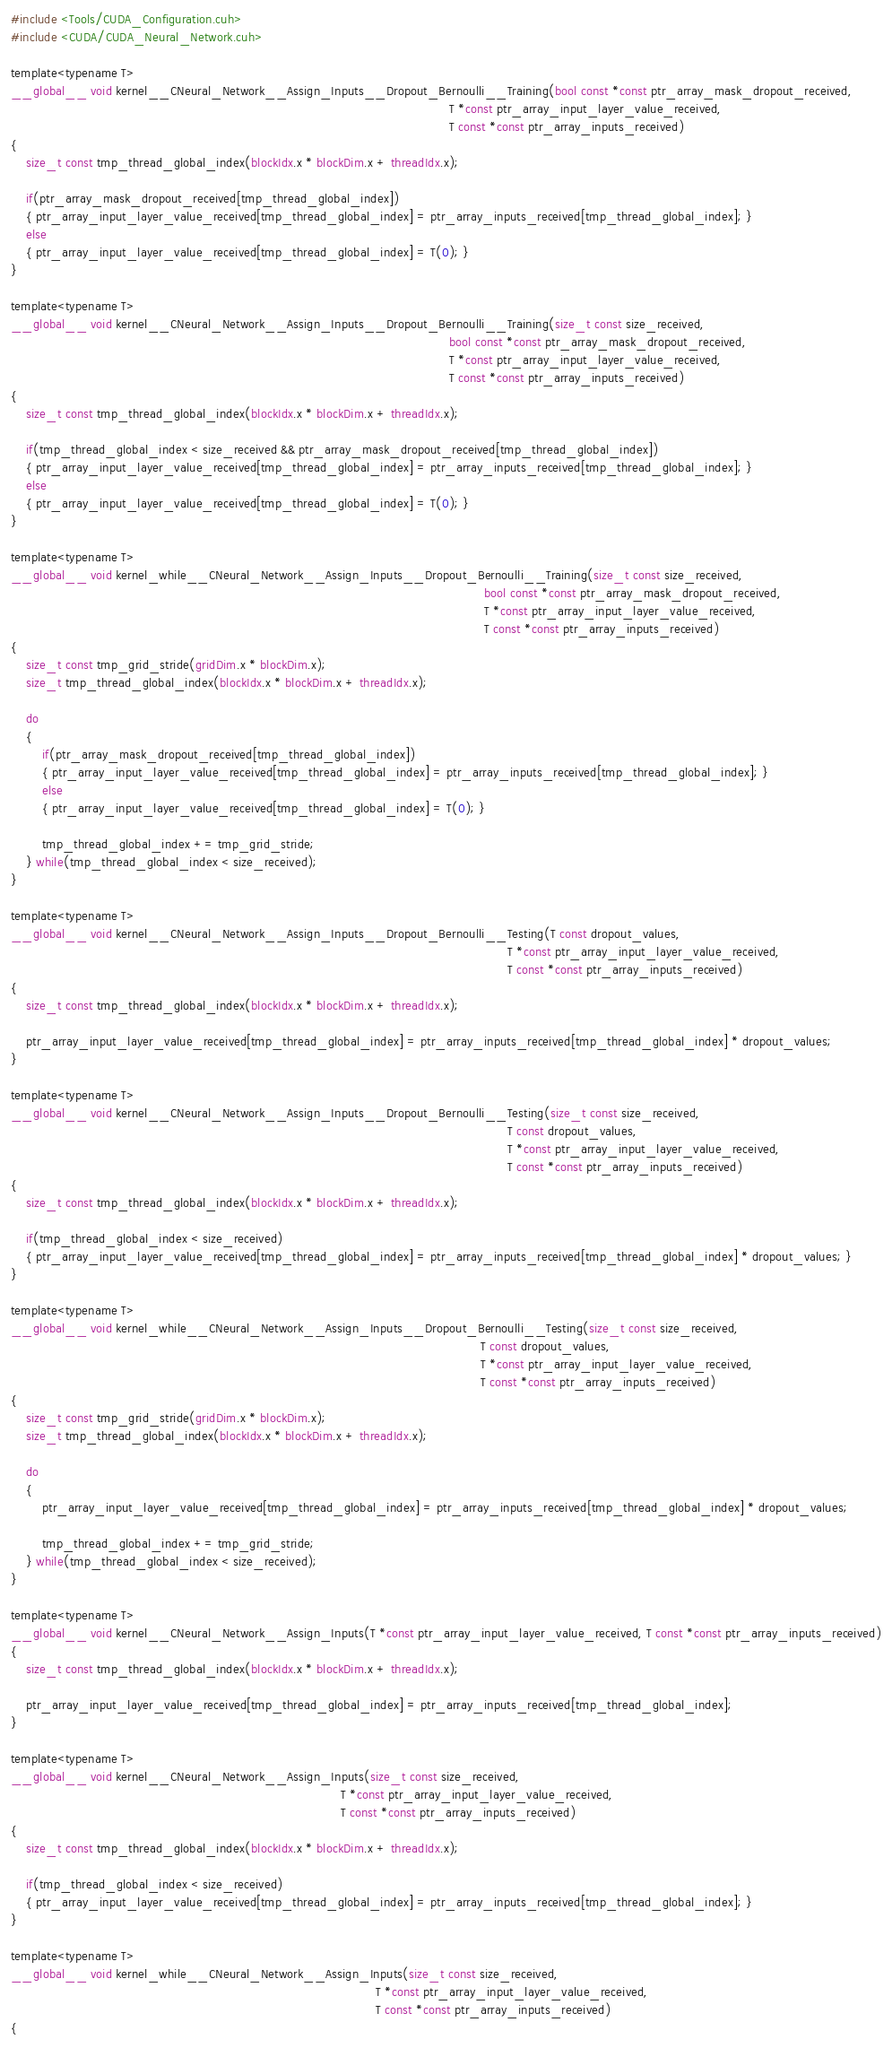<code> <loc_0><loc_0><loc_500><loc_500><_Cuda_>#include <Tools/CUDA_Configuration.cuh>
#include <CUDA/CUDA_Neural_Network.cuh>

template<typename T>
__global__ void kernel__CNeural_Network__Assign_Inputs__Dropout_Bernoulli__Training(bool const *const ptr_array_mask_dropout_received,
                                                                                                                 T *const ptr_array_input_layer_value_received,
                                                                                                                 T const *const ptr_array_inputs_received)
{
    size_t const tmp_thread_global_index(blockIdx.x * blockDim.x + threadIdx.x);
    
    if(ptr_array_mask_dropout_received[tmp_thread_global_index])
    { ptr_array_input_layer_value_received[tmp_thread_global_index] = ptr_array_inputs_received[tmp_thread_global_index]; }
    else
    { ptr_array_input_layer_value_received[tmp_thread_global_index] = T(0); }
}

template<typename T>
__global__ void kernel__CNeural_Network__Assign_Inputs__Dropout_Bernoulli__Training(size_t const size_received,
                                                                                                                 bool const *const ptr_array_mask_dropout_received,
                                                                                                                 T *const ptr_array_input_layer_value_received,
                                                                                                                 T const *const ptr_array_inputs_received)
{
    size_t const tmp_thread_global_index(blockIdx.x * blockDim.x + threadIdx.x);
    
    if(tmp_thread_global_index < size_received && ptr_array_mask_dropout_received[tmp_thread_global_index])
    { ptr_array_input_layer_value_received[tmp_thread_global_index] = ptr_array_inputs_received[tmp_thread_global_index]; }
    else
    { ptr_array_input_layer_value_received[tmp_thread_global_index] = T(0); }
}

template<typename T>
__global__ void kernel_while__CNeural_Network__Assign_Inputs__Dropout_Bernoulli__Training(size_t const size_received,
                                                                                                                          bool const *const ptr_array_mask_dropout_received,
                                                                                                                          T *const ptr_array_input_layer_value_received,
                                                                                                                          T const *const ptr_array_inputs_received)
{
    size_t const tmp_grid_stride(gridDim.x * blockDim.x);
    size_t tmp_thread_global_index(blockIdx.x * blockDim.x + threadIdx.x);
    
    do
    {
        if(ptr_array_mask_dropout_received[tmp_thread_global_index])
        { ptr_array_input_layer_value_received[tmp_thread_global_index] = ptr_array_inputs_received[tmp_thread_global_index]; }
        else
        { ptr_array_input_layer_value_received[tmp_thread_global_index] = T(0); }

        tmp_thread_global_index += tmp_grid_stride;
    } while(tmp_thread_global_index < size_received);
}

template<typename T>
__global__ void kernel__CNeural_Network__Assign_Inputs__Dropout_Bernoulli__Testing(T const dropout_values,
                                                                                                                                T *const ptr_array_input_layer_value_received,
                                                                                                                                T const *const ptr_array_inputs_received)
{
    size_t const tmp_thread_global_index(blockIdx.x * blockDim.x + threadIdx.x);
    
    ptr_array_input_layer_value_received[tmp_thread_global_index] = ptr_array_inputs_received[tmp_thread_global_index] * dropout_values;
}

template<typename T>
__global__ void kernel__CNeural_Network__Assign_Inputs__Dropout_Bernoulli__Testing(size_t const size_received,
                                                                                                                                T const dropout_values,
                                                                                                                                T *const ptr_array_input_layer_value_received,
                                                                                                                                T const *const ptr_array_inputs_received)
{
    size_t const tmp_thread_global_index(blockIdx.x * blockDim.x + threadIdx.x);
    
    if(tmp_thread_global_index < size_received)
    { ptr_array_input_layer_value_received[tmp_thread_global_index] = ptr_array_inputs_received[tmp_thread_global_index] * dropout_values; }
}

template<typename T>
__global__ void kernel_while__CNeural_Network__Assign_Inputs__Dropout_Bernoulli__Testing(size_t const size_received,
                                                                                                                         T const dropout_values,
                                                                                                                         T *const ptr_array_input_layer_value_received,
                                                                                                                         T const *const ptr_array_inputs_received)
{
    size_t const tmp_grid_stride(gridDim.x * blockDim.x);
    size_t tmp_thread_global_index(blockIdx.x * blockDim.x + threadIdx.x);
    
    do
    {
        ptr_array_input_layer_value_received[tmp_thread_global_index] = ptr_array_inputs_received[tmp_thread_global_index] * dropout_values;

        tmp_thread_global_index += tmp_grid_stride;
    } while(tmp_thread_global_index < size_received);
}

template<typename T>
__global__ void kernel__CNeural_Network__Assign_Inputs(T *const ptr_array_input_layer_value_received, T const *const ptr_array_inputs_received)
{
    size_t const tmp_thread_global_index(blockIdx.x * blockDim.x + threadIdx.x);
    
    ptr_array_input_layer_value_received[tmp_thread_global_index] = ptr_array_inputs_received[tmp_thread_global_index];
}

template<typename T>
__global__ void kernel__CNeural_Network__Assign_Inputs(size_t const size_received,
                                                                                     T *const ptr_array_input_layer_value_received,
                                                                                     T const *const ptr_array_inputs_received)
{
    size_t const tmp_thread_global_index(blockIdx.x * blockDim.x + threadIdx.x);
        
    if(tmp_thread_global_index < size_received)
    { ptr_array_input_layer_value_received[tmp_thread_global_index] = ptr_array_inputs_received[tmp_thread_global_index]; }
}

template<typename T>
__global__ void kernel_while__CNeural_Network__Assign_Inputs(size_t const size_received,
                                                                                              T *const ptr_array_input_layer_value_received,
                                                                                              T const *const ptr_array_inputs_received)
{</code> 